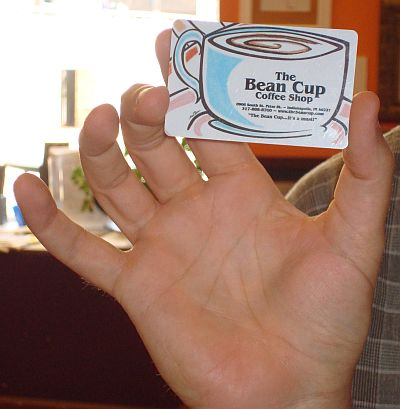<image>
Is there a gift card next to the window? No. The gift card is not positioned next to the window. They are located in different areas of the scene. 